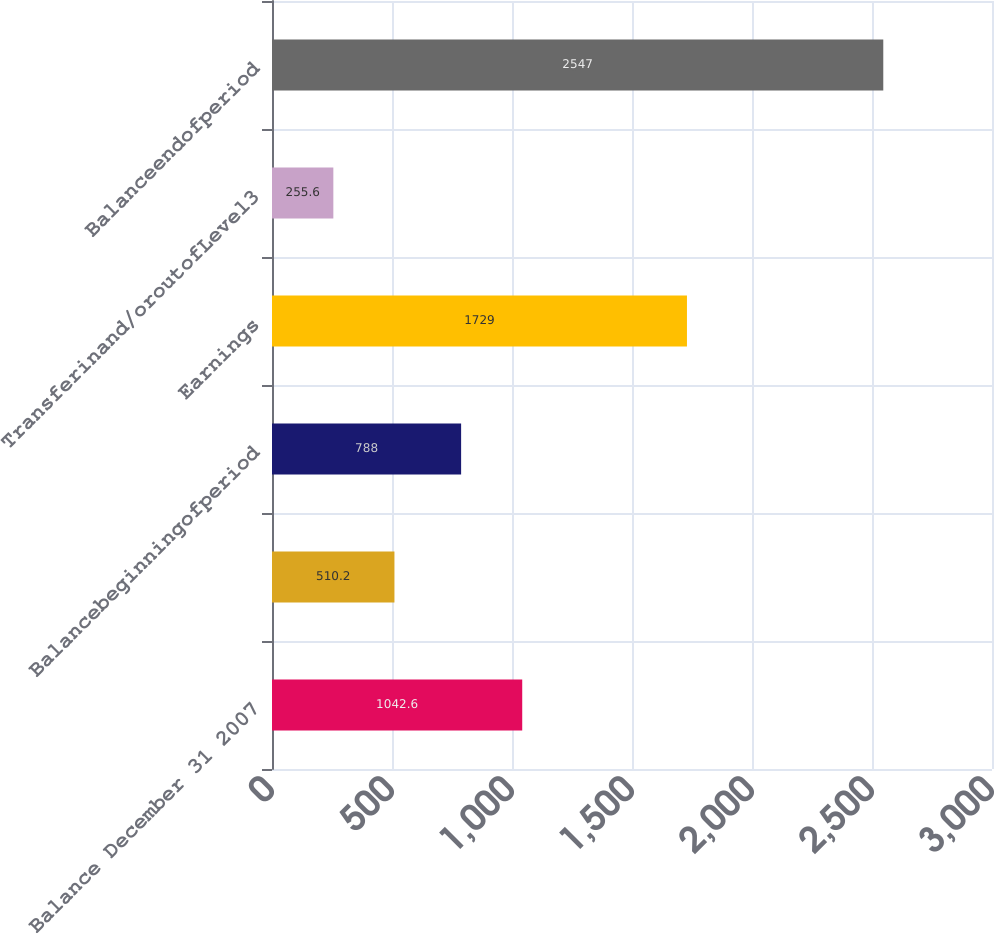Convert chart. <chart><loc_0><loc_0><loc_500><loc_500><bar_chart><fcel>Balance December 31 2007<fcel>Unnamed: 1<fcel>Balancebeginningofperiod<fcel>Earnings<fcel>Transferinand/oroutofLevel3<fcel>Balanceendofperiod<nl><fcel>1042.6<fcel>510.2<fcel>788<fcel>1729<fcel>255.6<fcel>2547<nl></chart> 